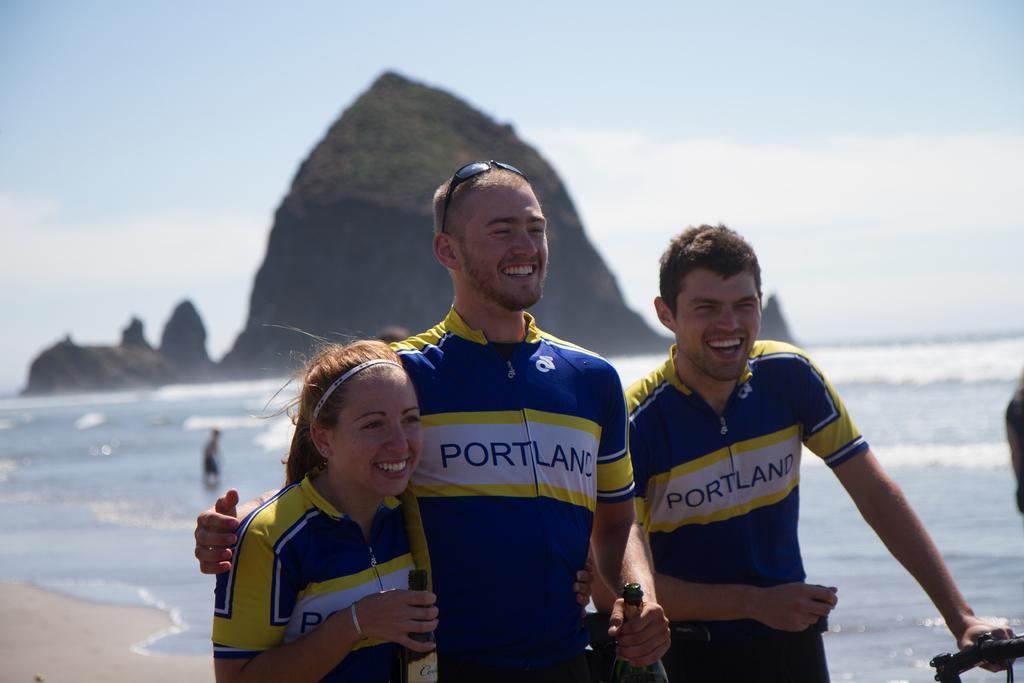<image>
Provide a brief description of the given image. A man wears a shirt with the word Portland on it. 